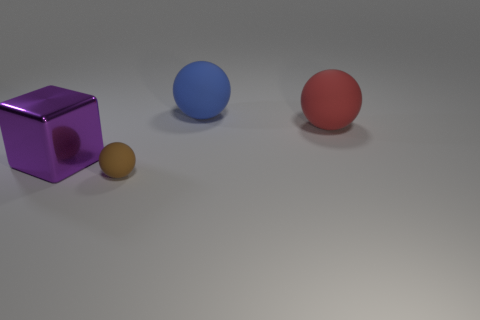What material is the thing left of the sphere that is in front of the purple metallic thing made of?
Provide a short and direct response. Metal. Are there more large purple things that are on the left side of the blue thing than gray rubber cubes?
Your answer should be very brief. Yes. The blue matte thing that is the same size as the purple metal thing is what shape?
Your answer should be compact. Sphere. There is a big object that is to the left of the matte ball that is in front of the metal cube; what number of blue spheres are to the left of it?
Make the answer very short. 0. How many rubber things are large cyan balls or big blocks?
Provide a succinct answer. 0. What is the color of the big thing that is to the left of the red rubber ball and behind the large cube?
Ensure brevity in your answer.  Blue. There is a rubber sphere right of the blue sphere; is its size the same as the tiny sphere?
Provide a succinct answer. No. What number of objects are either things that are to the left of the brown object or large matte balls?
Your response must be concise. 3. Is there a thing of the same size as the purple shiny cube?
Provide a succinct answer. Yes. There is a blue ball that is the same size as the red sphere; what is it made of?
Ensure brevity in your answer.  Rubber. 